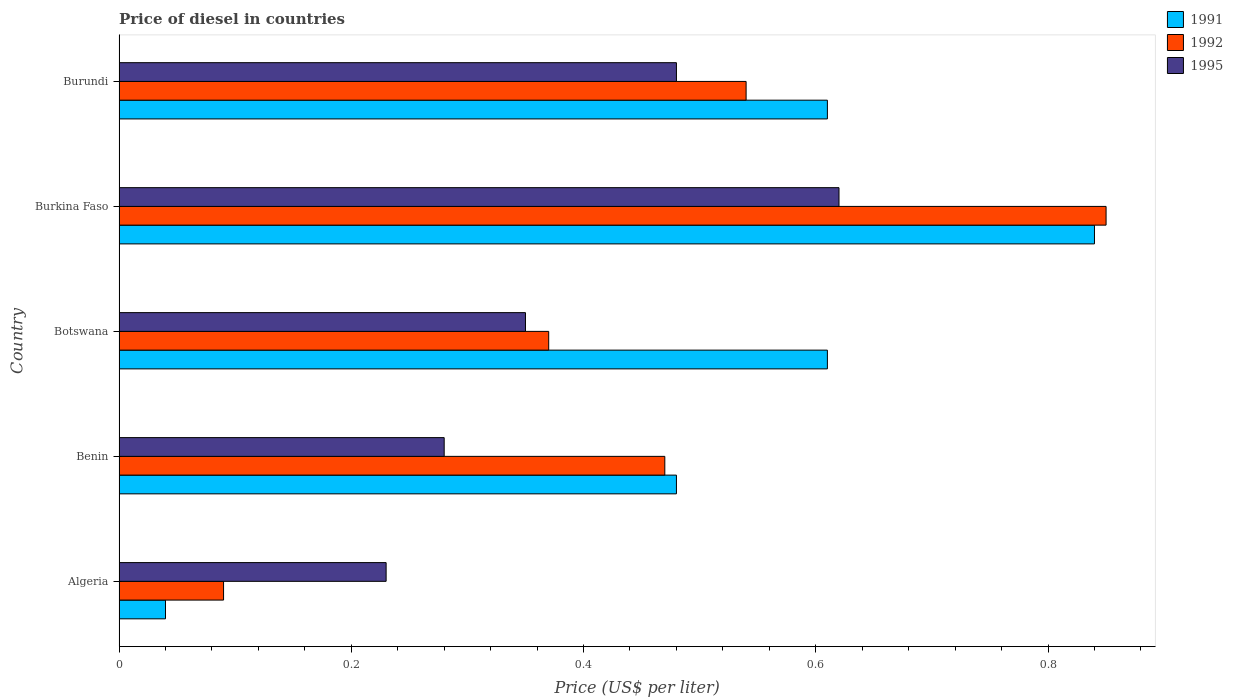How many groups of bars are there?
Keep it short and to the point. 5. Are the number of bars per tick equal to the number of legend labels?
Make the answer very short. Yes. How many bars are there on the 2nd tick from the bottom?
Give a very brief answer. 3. What is the label of the 1st group of bars from the top?
Ensure brevity in your answer.  Burundi. What is the price of diesel in 1991 in Benin?
Give a very brief answer. 0.48. Across all countries, what is the maximum price of diesel in 1991?
Give a very brief answer. 0.84. Across all countries, what is the minimum price of diesel in 1995?
Keep it short and to the point. 0.23. In which country was the price of diesel in 1991 maximum?
Give a very brief answer. Burkina Faso. In which country was the price of diesel in 1991 minimum?
Your answer should be compact. Algeria. What is the total price of diesel in 1991 in the graph?
Your answer should be very brief. 2.58. What is the difference between the price of diesel in 1995 in Benin and that in Burkina Faso?
Offer a terse response. -0.34. What is the difference between the price of diesel in 1991 in Burkina Faso and the price of diesel in 1992 in Benin?
Provide a short and direct response. 0.37. What is the average price of diesel in 1991 per country?
Provide a short and direct response. 0.52. What is the difference between the price of diesel in 1991 and price of diesel in 1992 in Burundi?
Make the answer very short. 0.07. In how many countries, is the price of diesel in 1991 greater than 0.56 US$?
Give a very brief answer. 3. What is the ratio of the price of diesel in 1992 in Algeria to that in Benin?
Your answer should be compact. 0.19. Is the price of diesel in 1995 in Botswana less than that in Burkina Faso?
Make the answer very short. Yes. What is the difference between the highest and the second highest price of diesel in 1992?
Give a very brief answer. 0.31. What is the difference between the highest and the lowest price of diesel in 1992?
Your answer should be very brief. 0.76. Is the sum of the price of diesel in 1992 in Algeria and Benin greater than the maximum price of diesel in 1995 across all countries?
Your answer should be very brief. No. How many bars are there?
Your response must be concise. 15. How many countries are there in the graph?
Your answer should be compact. 5. What is the difference between two consecutive major ticks on the X-axis?
Give a very brief answer. 0.2. Are the values on the major ticks of X-axis written in scientific E-notation?
Make the answer very short. No. Does the graph contain any zero values?
Provide a succinct answer. No. Where does the legend appear in the graph?
Ensure brevity in your answer.  Top right. How many legend labels are there?
Offer a terse response. 3. How are the legend labels stacked?
Offer a terse response. Vertical. What is the title of the graph?
Offer a terse response. Price of diesel in countries. Does "1977" appear as one of the legend labels in the graph?
Keep it short and to the point. No. What is the label or title of the X-axis?
Offer a very short reply. Price (US$ per liter). What is the label or title of the Y-axis?
Your response must be concise. Country. What is the Price (US$ per liter) in 1992 in Algeria?
Offer a very short reply. 0.09. What is the Price (US$ per liter) in 1995 in Algeria?
Provide a succinct answer. 0.23. What is the Price (US$ per liter) in 1991 in Benin?
Your answer should be compact. 0.48. What is the Price (US$ per liter) of 1992 in Benin?
Give a very brief answer. 0.47. What is the Price (US$ per liter) in 1995 in Benin?
Provide a succinct answer. 0.28. What is the Price (US$ per liter) in 1991 in Botswana?
Ensure brevity in your answer.  0.61. What is the Price (US$ per liter) in 1992 in Botswana?
Keep it short and to the point. 0.37. What is the Price (US$ per liter) in 1995 in Botswana?
Provide a short and direct response. 0.35. What is the Price (US$ per liter) of 1991 in Burkina Faso?
Offer a very short reply. 0.84. What is the Price (US$ per liter) in 1995 in Burkina Faso?
Provide a succinct answer. 0.62. What is the Price (US$ per liter) of 1991 in Burundi?
Your answer should be compact. 0.61. What is the Price (US$ per liter) in 1992 in Burundi?
Make the answer very short. 0.54. What is the Price (US$ per liter) in 1995 in Burundi?
Your response must be concise. 0.48. Across all countries, what is the maximum Price (US$ per liter) of 1991?
Keep it short and to the point. 0.84. Across all countries, what is the maximum Price (US$ per liter) of 1995?
Offer a very short reply. 0.62. Across all countries, what is the minimum Price (US$ per liter) in 1991?
Keep it short and to the point. 0.04. Across all countries, what is the minimum Price (US$ per liter) of 1992?
Provide a succinct answer. 0.09. Across all countries, what is the minimum Price (US$ per liter) of 1995?
Keep it short and to the point. 0.23. What is the total Price (US$ per liter) of 1991 in the graph?
Provide a succinct answer. 2.58. What is the total Price (US$ per liter) of 1992 in the graph?
Make the answer very short. 2.32. What is the total Price (US$ per liter) of 1995 in the graph?
Offer a terse response. 1.96. What is the difference between the Price (US$ per liter) of 1991 in Algeria and that in Benin?
Provide a succinct answer. -0.44. What is the difference between the Price (US$ per liter) in 1992 in Algeria and that in Benin?
Your response must be concise. -0.38. What is the difference between the Price (US$ per liter) of 1995 in Algeria and that in Benin?
Your response must be concise. -0.05. What is the difference between the Price (US$ per liter) of 1991 in Algeria and that in Botswana?
Make the answer very short. -0.57. What is the difference between the Price (US$ per liter) in 1992 in Algeria and that in Botswana?
Your response must be concise. -0.28. What is the difference between the Price (US$ per liter) of 1995 in Algeria and that in Botswana?
Ensure brevity in your answer.  -0.12. What is the difference between the Price (US$ per liter) of 1992 in Algeria and that in Burkina Faso?
Provide a short and direct response. -0.76. What is the difference between the Price (US$ per liter) of 1995 in Algeria and that in Burkina Faso?
Make the answer very short. -0.39. What is the difference between the Price (US$ per liter) in 1991 in Algeria and that in Burundi?
Your answer should be very brief. -0.57. What is the difference between the Price (US$ per liter) of 1992 in Algeria and that in Burundi?
Give a very brief answer. -0.45. What is the difference between the Price (US$ per liter) in 1995 in Algeria and that in Burundi?
Offer a terse response. -0.25. What is the difference between the Price (US$ per liter) of 1991 in Benin and that in Botswana?
Give a very brief answer. -0.13. What is the difference between the Price (US$ per liter) in 1995 in Benin and that in Botswana?
Provide a succinct answer. -0.07. What is the difference between the Price (US$ per liter) of 1991 in Benin and that in Burkina Faso?
Ensure brevity in your answer.  -0.36. What is the difference between the Price (US$ per liter) of 1992 in Benin and that in Burkina Faso?
Your answer should be compact. -0.38. What is the difference between the Price (US$ per liter) of 1995 in Benin and that in Burkina Faso?
Keep it short and to the point. -0.34. What is the difference between the Price (US$ per liter) of 1991 in Benin and that in Burundi?
Make the answer very short. -0.13. What is the difference between the Price (US$ per liter) in 1992 in Benin and that in Burundi?
Your answer should be compact. -0.07. What is the difference between the Price (US$ per liter) in 1995 in Benin and that in Burundi?
Your answer should be compact. -0.2. What is the difference between the Price (US$ per liter) in 1991 in Botswana and that in Burkina Faso?
Your response must be concise. -0.23. What is the difference between the Price (US$ per liter) of 1992 in Botswana and that in Burkina Faso?
Make the answer very short. -0.48. What is the difference between the Price (US$ per liter) of 1995 in Botswana and that in Burkina Faso?
Provide a short and direct response. -0.27. What is the difference between the Price (US$ per liter) of 1991 in Botswana and that in Burundi?
Your response must be concise. 0. What is the difference between the Price (US$ per liter) of 1992 in Botswana and that in Burundi?
Ensure brevity in your answer.  -0.17. What is the difference between the Price (US$ per liter) in 1995 in Botswana and that in Burundi?
Give a very brief answer. -0.13. What is the difference between the Price (US$ per liter) of 1991 in Burkina Faso and that in Burundi?
Offer a terse response. 0.23. What is the difference between the Price (US$ per liter) of 1992 in Burkina Faso and that in Burundi?
Offer a terse response. 0.31. What is the difference between the Price (US$ per liter) in 1995 in Burkina Faso and that in Burundi?
Ensure brevity in your answer.  0.14. What is the difference between the Price (US$ per liter) in 1991 in Algeria and the Price (US$ per liter) in 1992 in Benin?
Offer a very short reply. -0.43. What is the difference between the Price (US$ per liter) in 1991 in Algeria and the Price (US$ per liter) in 1995 in Benin?
Give a very brief answer. -0.24. What is the difference between the Price (US$ per liter) of 1992 in Algeria and the Price (US$ per liter) of 1995 in Benin?
Keep it short and to the point. -0.19. What is the difference between the Price (US$ per liter) in 1991 in Algeria and the Price (US$ per liter) in 1992 in Botswana?
Your answer should be compact. -0.33. What is the difference between the Price (US$ per liter) of 1991 in Algeria and the Price (US$ per liter) of 1995 in Botswana?
Make the answer very short. -0.31. What is the difference between the Price (US$ per liter) of 1992 in Algeria and the Price (US$ per liter) of 1995 in Botswana?
Keep it short and to the point. -0.26. What is the difference between the Price (US$ per liter) in 1991 in Algeria and the Price (US$ per liter) in 1992 in Burkina Faso?
Your response must be concise. -0.81. What is the difference between the Price (US$ per liter) in 1991 in Algeria and the Price (US$ per liter) in 1995 in Burkina Faso?
Your answer should be compact. -0.58. What is the difference between the Price (US$ per liter) in 1992 in Algeria and the Price (US$ per liter) in 1995 in Burkina Faso?
Provide a succinct answer. -0.53. What is the difference between the Price (US$ per liter) in 1991 in Algeria and the Price (US$ per liter) in 1992 in Burundi?
Your answer should be compact. -0.5. What is the difference between the Price (US$ per liter) of 1991 in Algeria and the Price (US$ per liter) of 1995 in Burundi?
Provide a short and direct response. -0.44. What is the difference between the Price (US$ per liter) in 1992 in Algeria and the Price (US$ per liter) in 1995 in Burundi?
Make the answer very short. -0.39. What is the difference between the Price (US$ per liter) of 1991 in Benin and the Price (US$ per liter) of 1992 in Botswana?
Your answer should be compact. 0.11. What is the difference between the Price (US$ per liter) of 1991 in Benin and the Price (US$ per liter) of 1995 in Botswana?
Provide a short and direct response. 0.13. What is the difference between the Price (US$ per liter) of 1992 in Benin and the Price (US$ per liter) of 1995 in Botswana?
Your response must be concise. 0.12. What is the difference between the Price (US$ per liter) in 1991 in Benin and the Price (US$ per liter) in 1992 in Burkina Faso?
Keep it short and to the point. -0.37. What is the difference between the Price (US$ per liter) of 1991 in Benin and the Price (US$ per liter) of 1995 in Burkina Faso?
Ensure brevity in your answer.  -0.14. What is the difference between the Price (US$ per liter) in 1992 in Benin and the Price (US$ per liter) in 1995 in Burkina Faso?
Offer a terse response. -0.15. What is the difference between the Price (US$ per liter) in 1991 in Benin and the Price (US$ per liter) in 1992 in Burundi?
Make the answer very short. -0.06. What is the difference between the Price (US$ per liter) in 1991 in Benin and the Price (US$ per liter) in 1995 in Burundi?
Your answer should be very brief. 0. What is the difference between the Price (US$ per liter) of 1992 in Benin and the Price (US$ per liter) of 1995 in Burundi?
Your answer should be compact. -0.01. What is the difference between the Price (US$ per liter) in 1991 in Botswana and the Price (US$ per liter) in 1992 in Burkina Faso?
Provide a succinct answer. -0.24. What is the difference between the Price (US$ per liter) of 1991 in Botswana and the Price (US$ per liter) of 1995 in Burkina Faso?
Offer a very short reply. -0.01. What is the difference between the Price (US$ per liter) of 1992 in Botswana and the Price (US$ per liter) of 1995 in Burkina Faso?
Provide a short and direct response. -0.25. What is the difference between the Price (US$ per liter) in 1991 in Botswana and the Price (US$ per liter) in 1992 in Burundi?
Your answer should be compact. 0.07. What is the difference between the Price (US$ per liter) in 1991 in Botswana and the Price (US$ per liter) in 1995 in Burundi?
Your answer should be very brief. 0.13. What is the difference between the Price (US$ per liter) in 1992 in Botswana and the Price (US$ per liter) in 1995 in Burundi?
Your response must be concise. -0.11. What is the difference between the Price (US$ per liter) in 1991 in Burkina Faso and the Price (US$ per liter) in 1995 in Burundi?
Your answer should be very brief. 0.36. What is the difference between the Price (US$ per liter) of 1992 in Burkina Faso and the Price (US$ per liter) of 1995 in Burundi?
Provide a succinct answer. 0.37. What is the average Price (US$ per liter) of 1991 per country?
Offer a very short reply. 0.52. What is the average Price (US$ per liter) of 1992 per country?
Your response must be concise. 0.46. What is the average Price (US$ per liter) of 1995 per country?
Offer a terse response. 0.39. What is the difference between the Price (US$ per liter) in 1991 and Price (US$ per liter) in 1992 in Algeria?
Your answer should be compact. -0.05. What is the difference between the Price (US$ per liter) of 1991 and Price (US$ per liter) of 1995 in Algeria?
Your answer should be very brief. -0.19. What is the difference between the Price (US$ per liter) in 1992 and Price (US$ per liter) in 1995 in Algeria?
Your answer should be very brief. -0.14. What is the difference between the Price (US$ per liter) in 1991 and Price (US$ per liter) in 1992 in Benin?
Provide a succinct answer. 0.01. What is the difference between the Price (US$ per liter) of 1992 and Price (US$ per liter) of 1995 in Benin?
Provide a succinct answer. 0.19. What is the difference between the Price (US$ per liter) of 1991 and Price (US$ per liter) of 1992 in Botswana?
Offer a very short reply. 0.24. What is the difference between the Price (US$ per liter) of 1991 and Price (US$ per liter) of 1995 in Botswana?
Your response must be concise. 0.26. What is the difference between the Price (US$ per liter) in 1991 and Price (US$ per liter) in 1992 in Burkina Faso?
Ensure brevity in your answer.  -0.01. What is the difference between the Price (US$ per liter) of 1991 and Price (US$ per liter) of 1995 in Burkina Faso?
Provide a succinct answer. 0.22. What is the difference between the Price (US$ per liter) in 1992 and Price (US$ per liter) in 1995 in Burkina Faso?
Offer a terse response. 0.23. What is the difference between the Price (US$ per liter) of 1991 and Price (US$ per liter) of 1992 in Burundi?
Make the answer very short. 0.07. What is the difference between the Price (US$ per liter) in 1991 and Price (US$ per liter) in 1995 in Burundi?
Offer a terse response. 0.13. What is the ratio of the Price (US$ per liter) of 1991 in Algeria to that in Benin?
Provide a succinct answer. 0.08. What is the ratio of the Price (US$ per liter) in 1992 in Algeria to that in Benin?
Your answer should be very brief. 0.19. What is the ratio of the Price (US$ per liter) of 1995 in Algeria to that in Benin?
Make the answer very short. 0.82. What is the ratio of the Price (US$ per liter) of 1991 in Algeria to that in Botswana?
Keep it short and to the point. 0.07. What is the ratio of the Price (US$ per liter) of 1992 in Algeria to that in Botswana?
Provide a short and direct response. 0.24. What is the ratio of the Price (US$ per liter) in 1995 in Algeria to that in Botswana?
Provide a succinct answer. 0.66. What is the ratio of the Price (US$ per liter) in 1991 in Algeria to that in Burkina Faso?
Provide a short and direct response. 0.05. What is the ratio of the Price (US$ per liter) in 1992 in Algeria to that in Burkina Faso?
Keep it short and to the point. 0.11. What is the ratio of the Price (US$ per liter) of 1995 in Algeria to that in Burkina Faso?
Provide a succinct answer. 0.37. What is the ratio of the Price (US$ per liter) in 1991 in Algeria to that in Burundi?
Offer a terse response. 0.07. What is the ratio of the Price (US$ per liter) of 1995 in Algeria to that in Burundi?
Offer a terse response. 0.48. What is the ratio of the Price (US$ per liter) in 1991 in Benin to that in Botswana?
Keep it short and to the point. 0.79. What is the ratio of the Price (US$ per liter) of 1992 in Benin to that in Botswana?
Give a very brief answer. 1.27. What is the ratio of the Price (US$ per liter) of 1995 in Benin to that in Botswana?
Your answer should be compact. 0.8. What is the ratio of the Price (US$ per liter) in 1991 in Benin to that in Burkina Faso?
Your response must be concise. 0.57. What is the ratio of the Price (US$ per liter) in 1992 in Benin to that in Burkina Faso?
Give a very brief answer. 0.55. What is the ratio of the Price (US$ per liter) of 1995 in Benin to that in Burkina Faso?
Give a very brief answer. 0.45. What is the ratio of the Price (US$ per liter) of 1991 in Benin to that in Burundi?
Your answer should be compact. 0.79. What is the ratio of the Price (US$ per liter) of 1992 in Benin to that in Burundi?
Your answer should be very brief. 0.87. What is the ratio of the Price (US$ per liter) of 1995 in Benin to that in Burundi?
Your response must be concise. 0.58. What is the ratio of the Price (US$ per liter) of 1991 in Botswana to that in Burkina Faso?
Your answer should be compact. 0.73. What is the ratio of the Price (US$ per liter) in 1992 in Botswana to that in Burkina Faso?
Provide a succinct answer. 0.44. What is the ratio of the Price (US$ per liter) of 1995 in Botswana to that in Burkina Faso?
Provide a short and direct response. 0.56. What is the ratio of the Price (US$ per liter) in 1992 in Botswana to that in Burundi?
Give a very brief answer. 0.69. What is the ratio of the Price (US$ per liter) of 1995 in Botswana to that in Burundi?
Ensure brevity in your answer.  0.73. What is the ratio of the Price (US$ per liter) of 1991 in Burkina Faso to that in Burundi?
Your answer should be compact. 1.38. What is the ratio of the Price (US$ per liter) of 1992 in Burkina Faso to that in Burundi?
Offer a terse response. 1.57. What is the ratio of the Price (US$ per liter) of 1995 in Burkina Faso to that in Burundi?
Provide a short and direct response. 1.29. What is the difference between the highest and the second highest Price (US$ per liter) of 1991?
Keep it short and to the point. 0.23. What is the difference between the highest and the second highest Price (US$ per liter) of 1992?
Offer a very short reply. 0.31. What is the difference between the highest and the second highest Price (US$ per liter) of 1995?
Provide a short and direct response. 0.14. What is the difference between the highest and the lowest Price (US$ per liter) in 1992?
Give a very brief answer. 0.76. What is the difference between the highest and the lowest Price (US$ per liter) of 1995?
Keep it short and to the point. 0.39. 